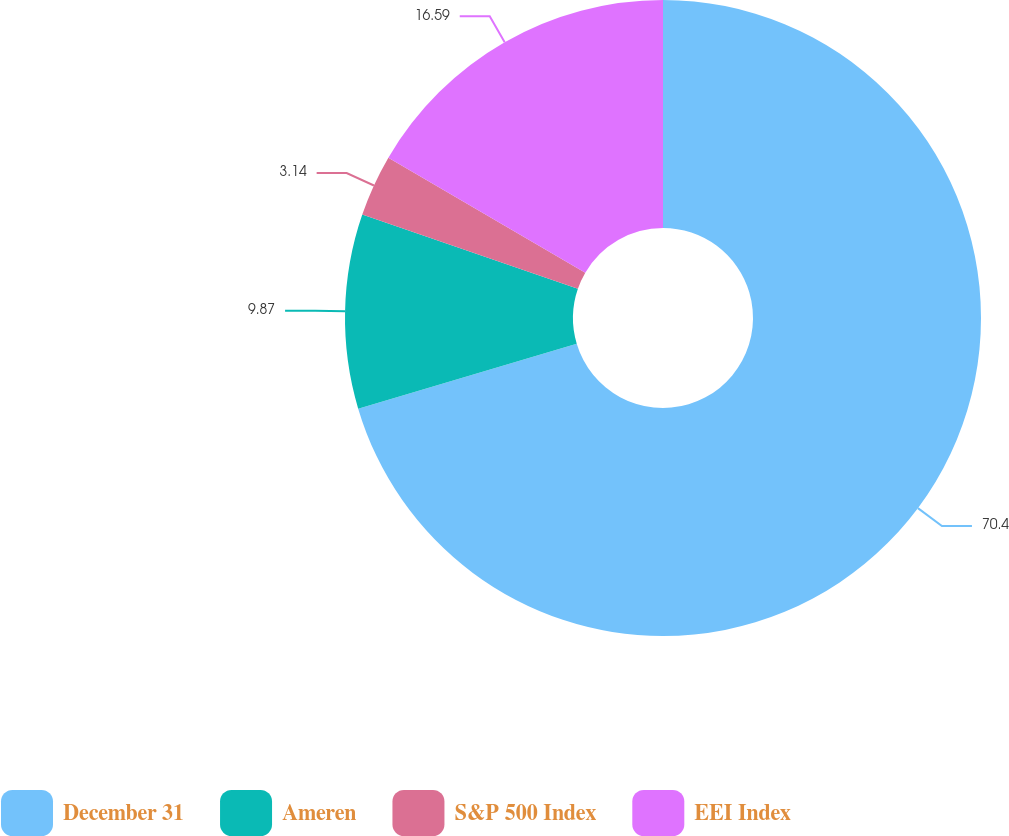Convert chart. <chart><loc_0><loc_0><loc_500><loc_500><pie_chart><fcel>December 31<fcel>Ameren<fcel>S&P 500 Index<fcel>EEI Index<nl><fcel>70.4%<fcel>9.87%<fcel>3.14%<fcel>16.59%<nl></chart> 